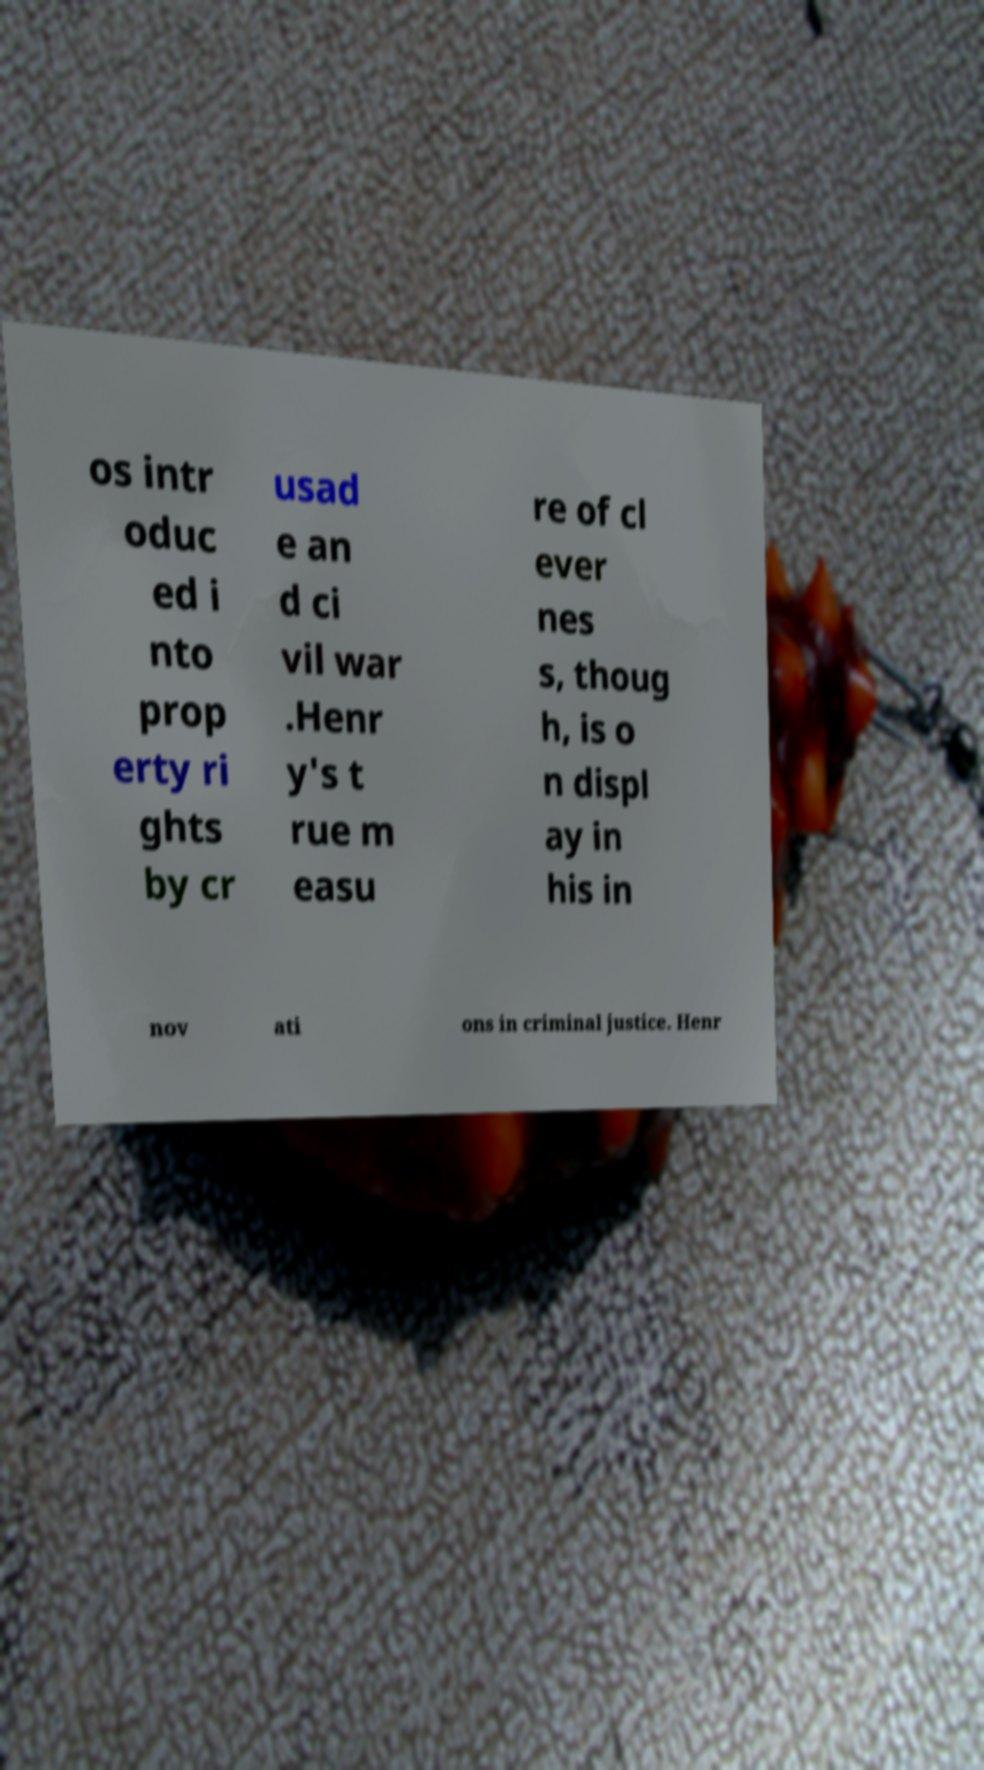Please read and relay the text visible in this image. What does it say? os intr oduc ed i nto prop erty ri ghts by cr usad e an d ci vil war .Henr y's t rue m easu re of cl ever nes s, thoug h, is o n displ ay in his in nov ati ons in criminal justice. Henr 